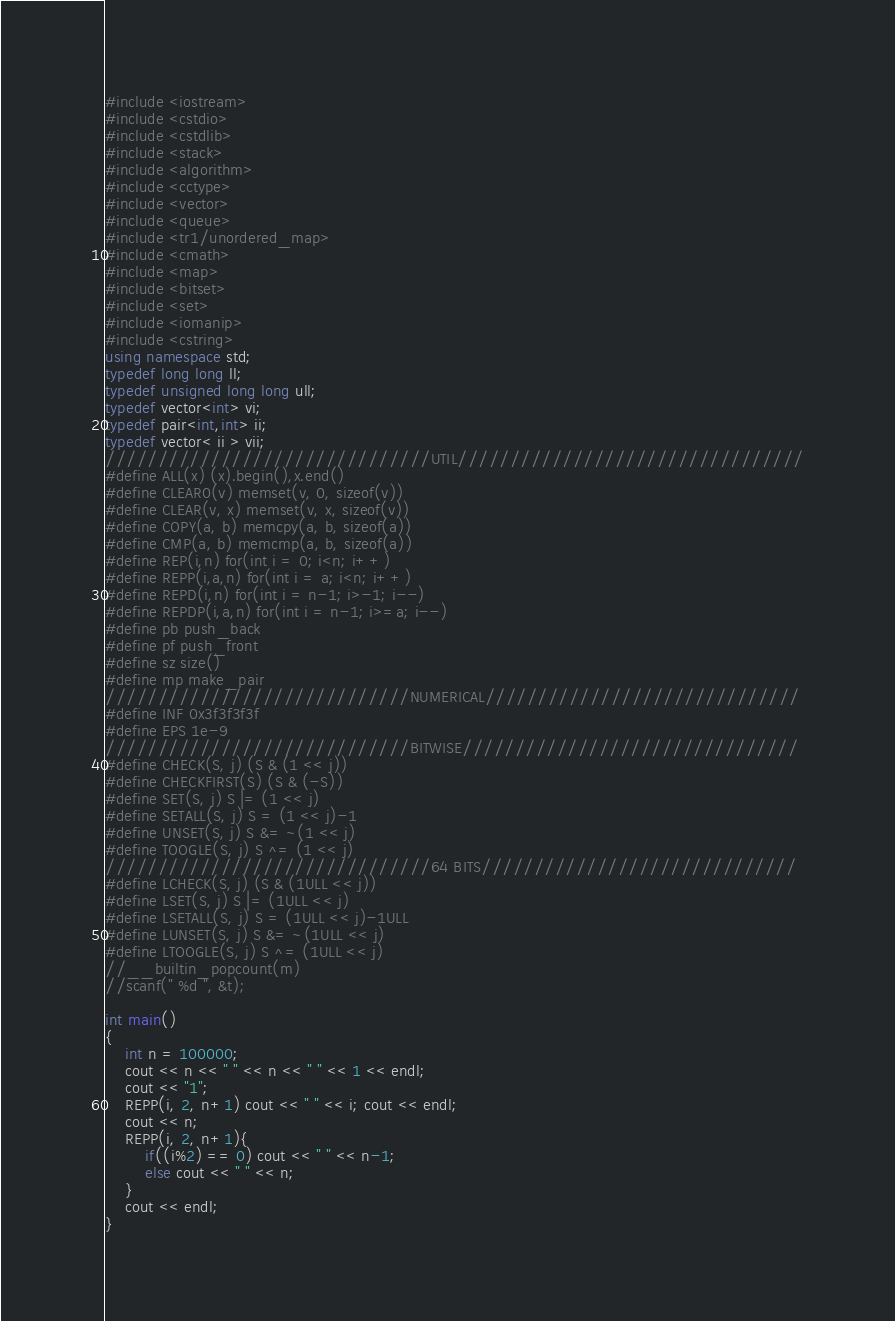<code> <loc_0><loc_0><loc_500><loc_500><_C++_>#include <iostream>
#include <cstdio>
#include <cstdlib>
#include <stack>
#include <algorithm>
#include <cctype>
#include <vector>
#include <queue>
#include <tr1/unordered_map>
#include <cmath>
#include <map>
#include <bitset>
#include <set>
#include <iomanip>
#include <cstring>
using namespace std;
typedef long long ll;
typedef unsigned long long ull;
typedef vector<int> vi;
typedef pair<int,int> ii;
typedef vector< ii > vii;
///////////////////////////////UTIL/////////////////////////////////
#define ALL(x) (x).begin(),x.end()
#define CLEAR0(v) memset(v, 0, sizeof(v))
#define CLEAR(v, x) memset(v, x, sizeof(v))
#define COPY(a, b) memcpy(a, b, sizeof(a))
#define CMP(a, b) memcmp(a, b, sizeof(a))
#define REP(i,n) for(int i = 0; i<n; i++)
#define REPP(i,a,n) for(int i = a; i<n; i++)
#define REPD(i,n) for(int i = n-1; i>-1; i--)
#define REPDP(i,a,n) for(int i = n-1; i>=a; i--)
#define pb push_back
#define pf push_front
#define sz size()
#define mp make_pair
/////////////////////////////NUMERICAL//////////////////////////////
#define INF 0x3f3f3f3f
#define EPS 1e-9
/////////////////////////////BITWISE////////////////////////////////
#define CHECK(S, j) (S & (1 << j))
#define CHECKFIRST(S) (S & (-S)) 
#define SET(S, j) S |= (1 << j)
#define SETALL(S, j) S = (1 << j)-1  
#define UNSET(S, j) S &= ~(1 << j)
#define TOOGLE(S, j) S ^= (1 << j)
///////////////////////////////64 BITS//////////////////////////////
#define LCHECK(S, j) (S & (1ULL << j))
#define LSET(S, j) S |= (1ULL << j)
#define LSETALL(S, j) S = (1ULL << j)-1ULL 
#define LUNSET(S, j) S &= ~(1ULL << j)
#define LTOOGLE(S, j) S ^= (1ULL << j)
//__builtin_popcount(m)
//scanf(" %d ", &t);

int main()
{
    int n = 100000;
    cout << n << " " << n << " " << 1 << endl;
    cout << "1";
    REPP(i, 2, n+1) cout << " " << i; cout << endl;
    cout << n;
    REPP(i, 2, n+1){
		if((i%2) == 0) cout << " " << n-1;
		else cout << " " << n;
	}
	cout << endl;
}
</code> 